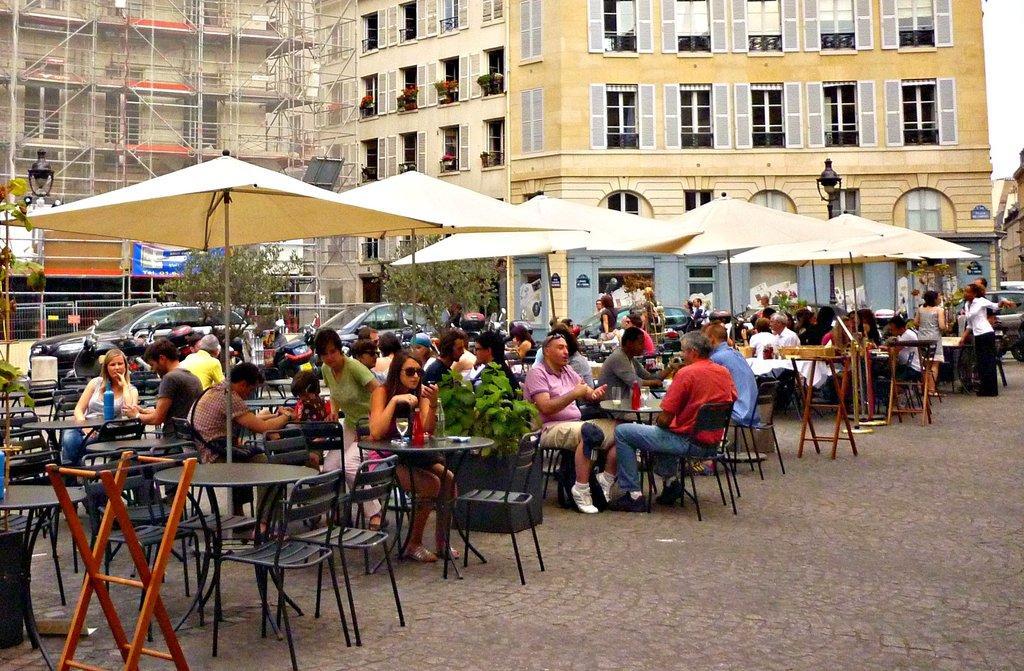Please provide a concise description of this image. This is looking like food court. So many people are sitting in this food court. There are chairs and tables in this food court. There are tents also in this food court. In the back there are two trees. Also there are two cars parked in this. And at the background there is a building and this building consist of windows also there is a construction of building going on. There is a lamp in the background. 